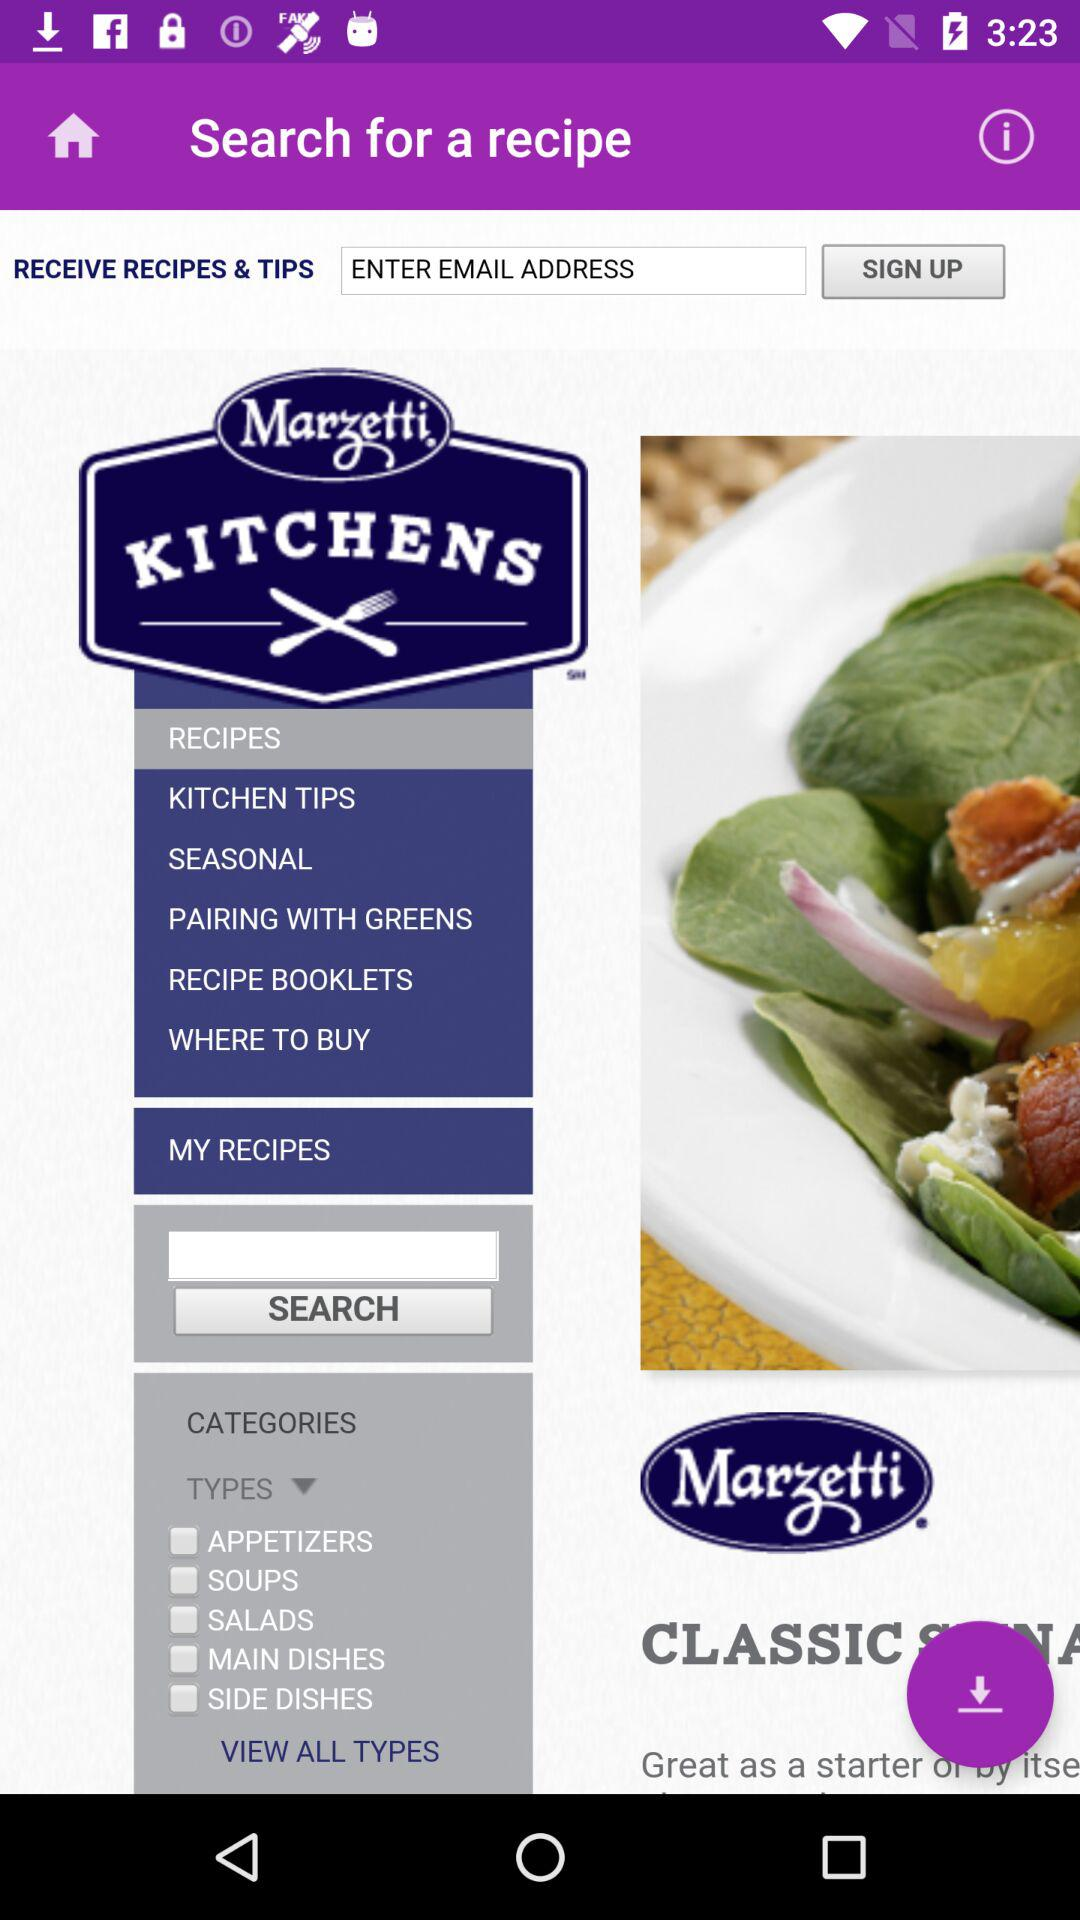What is the requirement to get a "SIGN UP"? The requirement to get signed up is "EMAIL ADDRESS". 